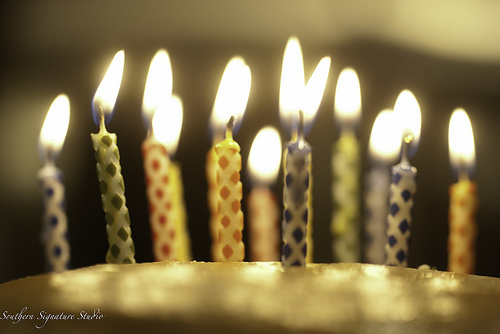<image>
Is the flame on the cake? Yes. Looking at the image, I can see the flame is positioned on top of the cake, with the cake providing support. 